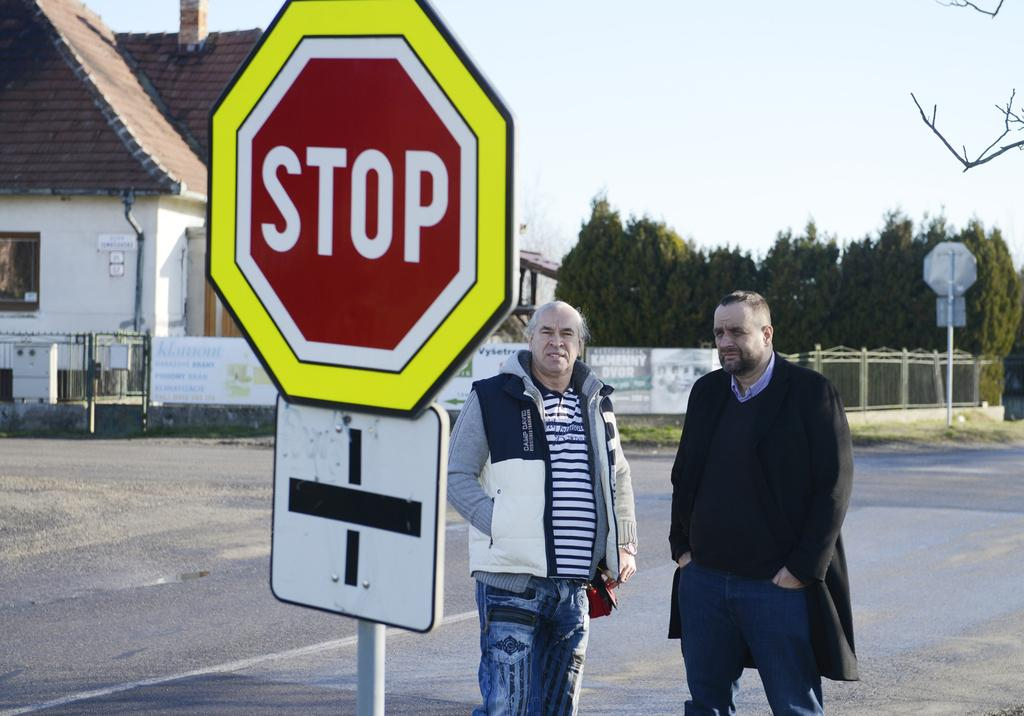<image>
Present a compact description of the photo's key features. Two men standing beside a stop sign in the road 